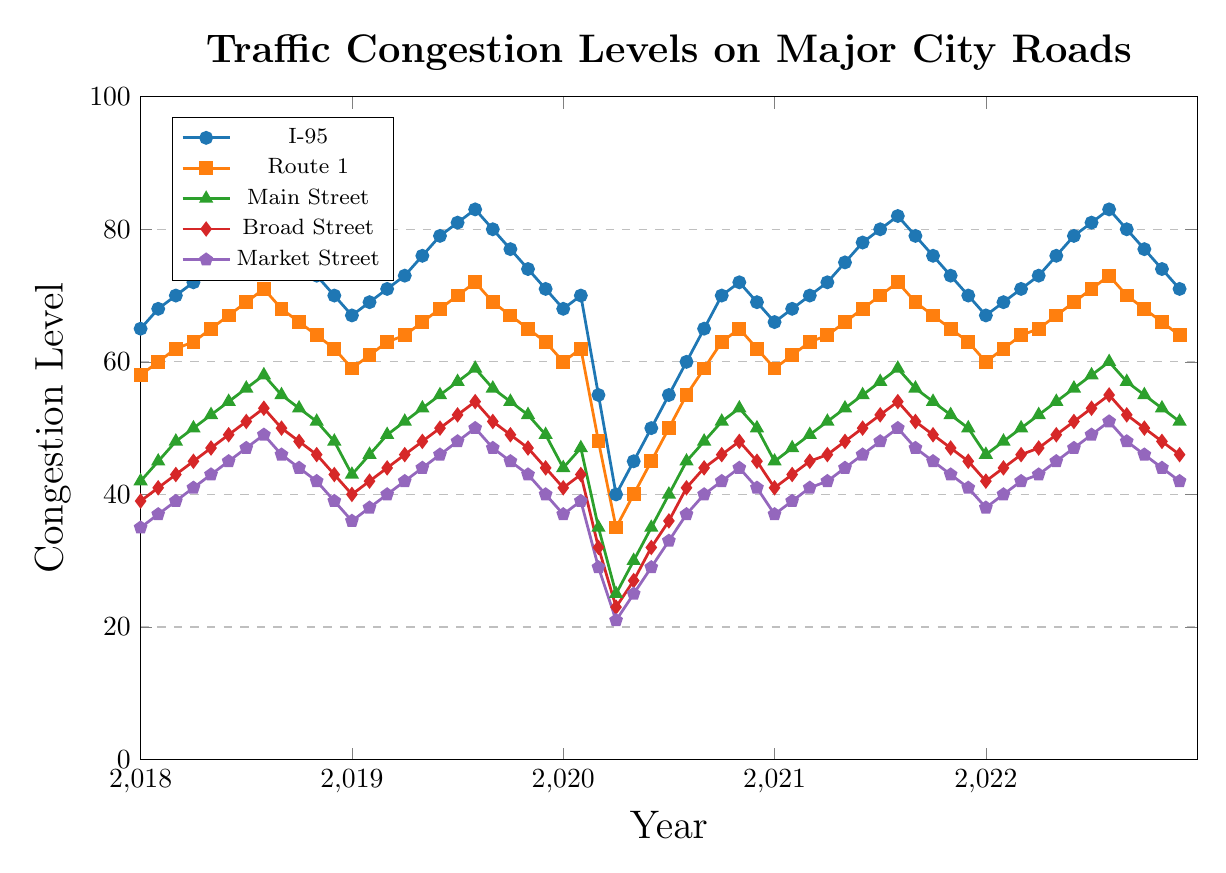Which road had the lowest congestion level in April 2020? Look at the congestion levels for all five roads in April 2020. Main Street had the lowest congestion level with 25.
Answer: Main Street How did the congestion level on Market Street in July 2020 compare to that in July 2019? Check the congestion levels for Market Street in both Julys: 37 in July 2020 and 48 in July 2019. The congestion level in July 2020 was lower.
Answer: Lower During which period did I-95 see a significant drop in congestion levels? Scan through I-95 levels; a noticeable drop occurs between February and March 2020, from 70 to 55, and a further drop to 40 in April 2020.
Answer: Between February and April 2020 What was the average congestion level for Broad Street during the year 2018? Sum the monthly values: 39 + 41 + 43 + 45 + 47 + 49 + 51 + 53 + 50 + 48 + 46 + 43 = 545. Then, divide by 12.
Answer: 45.42 Did Main Street or Route 1 experience a higher peak congestion level over the 5 years? Identify peak congestion levels: Main Street peaked at 60 in August 2022, while Route 1 peaked at 73 in August 2022. Compare the two values.
Answer: Route 1 What visual trend do you notice for Market Street from January to December 2020? Visually follow the Market Street line from January to December 2020: it drops sharply from January to April, then gradually rises back.
Answer: Sharp drop, then gradual rise Which month saw the highest congestion level on I-95 throughout the entire period, and what was its value? Scan the I-95 line for peaks: it was highest in August 2019 and August 2022, both at 83.
Answer: August 2019 and August 2022, 83 By how much did the congestion level of Broad Street decrease from February to April 2020? Check the values: February 2020 - 43, April 2020 - 23. The decrease is 43 - 23 = 20.
Answer: 20 